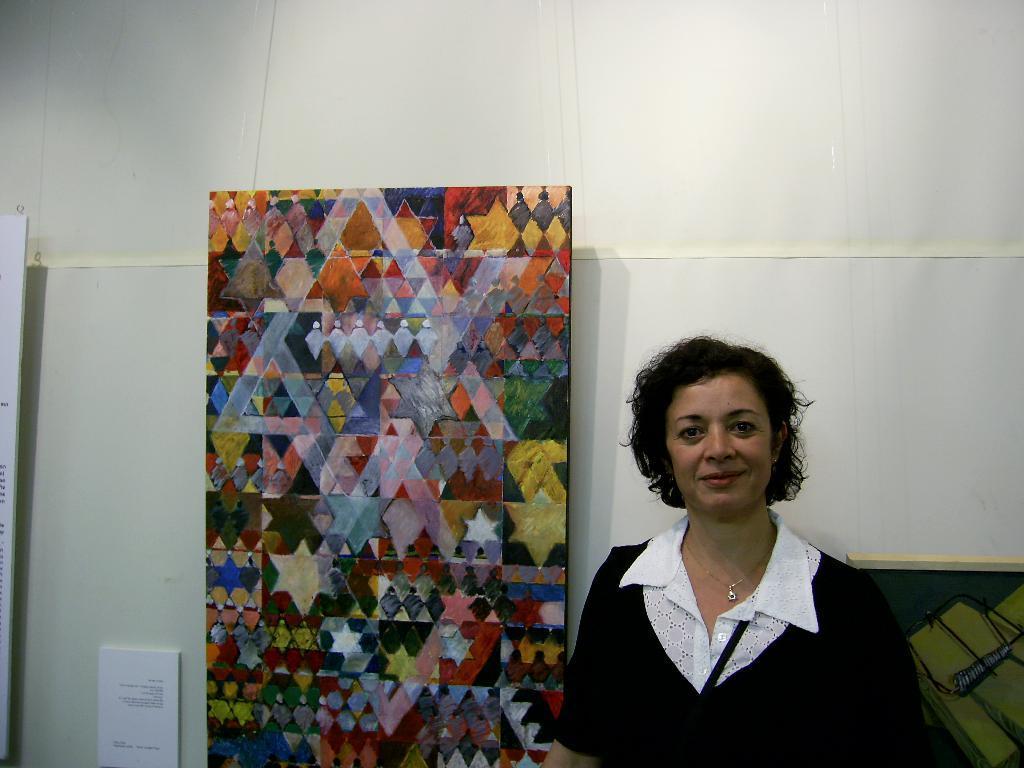Describe this image in one or two sentences. In this picture there is a woman wearing black and white color top smiling and giving a pose into the camera. Beside there is a abstract art poster. Behind there is a white banner wall. 